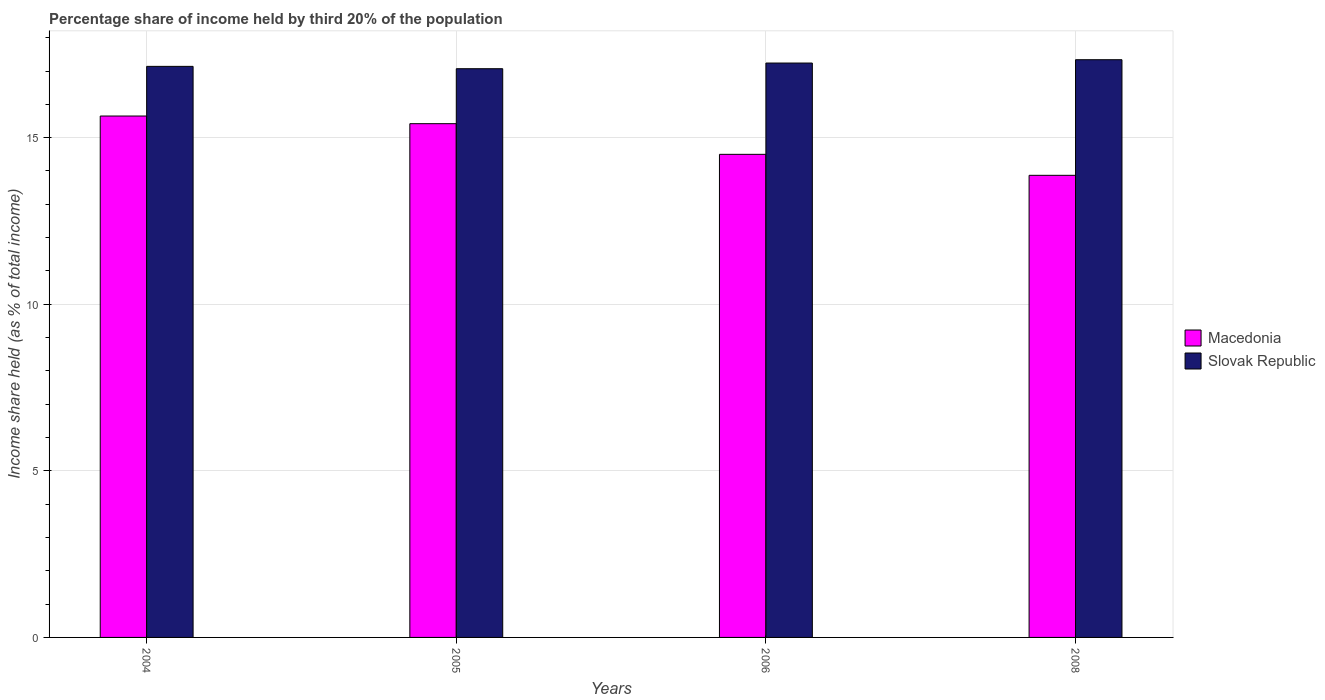How many groups of bars are there?
Offer a terse response. 4. Are the number of bars per tick equal to the number of legend labels?
Give a very brief answer. Yes. How many bars are there on the 1st tick from the right?
Provide a short and direct response. 2. In how many cases, is the number of bars for a given year not equal to the number of legend labels?
Your answer should be very brief. 0. What is the share of income held by third 20% of the population in Macedonia in 2008?
Ensure brevity in your answer.  13.87. Across all years, what is the maximum share of income held by third 20% of the population in Slovak Republic?
Keep it short and to the point. 17.34. Across all years, what is the minimum share of income held by third 20% of the population in Slovak Republic?
Keep it short and to the point. 17.07. What is the total share of income held by third 20% of the population in Slovak Republic in the graph?
Make the answer very short. 68.79. What is the difference between the share of income held by third 20% of the population in Slovak Republic in 2005 and that in 2008?
Keep it short and to the point. -0.27. What is the difference between the share of income held by third 20% of the population in Macedonia in 2006 and the share of income held by third 20% of the population in Slovak Republic in 2004?
Ensure brevity in your answer.  -2.64. What is the average share of income held by third 20% of the population in Macedonia per year?
Provide a succinct answer. 14.86. In the year 2008, what is the difference between the share of income held by third 20% of the population in Macedonia and share of income held by third 20% of the population in Slovak Republic?
Your answer should be very brief. -3.47. In how many years, is the share of income held by third 20% of the population in Macedonia greater than 6 %?
Your answer should be compact. 4. What is the ratio of the share of income held by third 20% of the population in Macedonia in 2004 to that in 2005?
Provide a succinct answer. 1.01. Is the difference between the share of income held by third 20% of the population in Macedonia in 2006 and 2008 greater than the difference between the share of income held by third 20% of the population in Slovak Republic in 2006 and 2008?
Offer a terse response. Yes. What is the difference between the highest and the second highest share of income held by third 20% of the population in Macedonia?
Give a very brief answer. 0.23. What is the difference between the highest and the lowest share of income held by third 20% of the population in Macedonia?
Your answer should be very brief. 1.78. In how many years, is the share of income held by third 20% of the population in Slovak Republic greater than the average share of income held by third 20% of the population in Slovak Republic taken over all years?
Offer a very short reply. 2. Is the sum of the share of income held by third 20% of the population in Macedonia in 2004 and 2006 greater than the maximum share of income held by third 20% of the population in Slovak Republic across all years?
Provide a succinct answer. Yes. What does the 1st bar from the left in 2008 represents?
Provide a succinct answer. Macedonia. What does the 1st bar from the right in 2008 represents?
Give a very brief answer. Slovak Republic. How many bars are there?
Make the answer very short. 8. Are all the bars in the graph horizontal?
Keep it short and to the point. No. How many years are there in the graph?
Ensure brevity in your answer.  4. Are the values on the major ticks of Y-axis written in scientific E-notation?
Provide a succinct answer. No. Does the graph contain any zero values?
Keep it short and to the point. No. Where does the legend appear in the graph?
Your response must be concise. Center right. How many legend labels are there?
Offer a terse response. 2. What is the title of the graph?
Provide a succinct answer. Percentage share of income held by third 20% of the population. What is the label or title of the X-axis?
Keep it short and to the point. Years. What is the label or title of the Y-axis?
Your answer should be compact. Income share held (as % of total income). What is the Income share held (as % of total income) of Macedonia in 2004?
Give a very brief answer. 15.65. What is the Income share held (as % of total income) of Slovak Republic in 2004?
Your answer should be very brief. 17.14. What is the Income share held (as % of total income) in Macedonia in 2005?
Ensure brevity in your answer.  15.42. What is the Income share held (as % of total income) of Slovak Republic in 2005?
Keep it short and to the point. 17.07. What is the Income share held (as % of total income) of Slovak Republic in 2006?
Provide a short and direct response. 17.24. What is the Income share held (as % of total income) in Macedonia in 2008?
Ensure brevity in your answer.  13.87. What is the Income share held (as % of total income) of Slovak Republic in 2008?
Ensure brevity in your answer.  17.34. Across all years, what is the maximum Income share held (as % of total income) in Macedonia?
Offer a terse response. 15.65. Across all years, what is the maximum Income share held (as % of total income) of Slovak Republic?
Keep it short and to the point. 17.34. Across all years, what is the minimum Income share held (as % of total income) of Macedonia?
Offer a very short reply. 13.87. Across all years, what is the minimum Income share held (as % of total income) of Slovak Republic?
Keep it short and to the point. 17.07. What is the total Income share held (as % of total income) in Macedonia in the graph?
Provide a short and direct response. 59.44. What is the total Income share held (as % of total income) in Slovak Republic in the graph?
Keep it short and to the point. 68.79. What is the difference between the Income share held (as % of total income) of Macedonia in 2004 and that in 2005?
Provide a short and direct response. 0.23. What is the difference between the Income share held (as % of total income) in Slovak Republic in 2004 and that in 2005?
Keep it short and to the point. 0.07. What is the difference between the Income share held (as % of total income) of Macedonia in 2004 and that in 2006?
Give a very brief answer. 1.15. What is the difference between the Income share held (as % of total income) in Macedonia in 2004 and that in 2008?
Your answer should be very brief. 1.78. What is the difference between the Income share held (as % of total income) of Macedonia in 2005 and that in 2006?
Ensure brevity in your answer.  0.92. What is the difference between the Income share held (as % of total income) of Slovak Republic in 2005 and that in 2006?
Your answer should be compact. -0.17. What is the difference between the Income share held (as % of total income) of Macedonia in 2005 and that in 2008?
Provide a short and direct response. 1.55. What is the difference between the Income share held (as % of total income) of Slovak Republic in 2005 and that in 2008?
Offer a terse response. -0.27. What is the difference between the Income share held (as % of total income) in Macedonia in 2006 and that in 2008?
Your answer should be compact. 0.63. What is the difference between the Income share held (as % of total income) in Macedonia in 2004 and the Income share held (as % of total income) in Slovak Republic in 2005?
Make the answer very short. -1.42. What is the difference between the Income share held (as % of total income) of Macedonia in 2004 and the Income share held (as % of total income) of Slovak Republic in 2006?
Offer a terse response. -1.59. What is the difference between the Income share held (as % of total income) in Macedonia in 2004 and the Income share held (as % of total income) in Slovak Republic in 2008?
Offer a terse response. -1.69. What is the difference between the Income share held (as % of total income) of Macedonia in 2005 and the Income share held (as % of total income) of Slovak Republic in 2006?
Make the answer very short. -1.82. What is the difference between the Income share held (as % of total income) of Macedonia in 2005 and the Income share held (as % of total income) of Slovak Republic in 2008?
Ensure brevity in your answer.  -1.92. What is the difference between the Income share held (as % of total income) in Macedonia in 2006 and the Income share held (as % of total income) in Slovak Republic in 2008?
Give a very brief answer. -2.84. What is the average Income share held (as % of total income) of Macedonia per year?
Your answer should be very brief. 14.86. What is the average Income share held (as % of total income) in Slovak Republic per year?
Ensure brevity in your answer.  17.2. In the year 2004, what is the difference between the Income share held (as % of total income) in Macedonia and Income share held (as % of total income) in Slovak Republic?
Offer a very short reply. -1.49. In the year 2005, what is the difference between the Income share held (as % of total income) in Macedonia and Income share held (as % of total income) in Slovak Republic?
Keep it short and to the point. -1.65. In the year 2006, what is the difference between the Income share held (as % of total income) of Macedonia and Income share held (as % of total income) of Slovak Republic?
Keep it short and to the point. -2.74. In the year 2008, what is the difference between the Income share held (as % of total income) in Macedonia and Income share held (as % of total income) in Slovak Republic?
Offer a very short reply. -3.47. What is the ratio of the Income share held (as % of total income) of Macedonia in 2004 to that in 2005?
Make the answer very short. 1.01. What is the ratio of the Income share held (as % of total income) in Slovak Republic in 2004 to that in 2005?
Ensure brevity in your answer.  1. What is the ratio of the Income share held (as % of total income) in Macedonia in 2004 to that in 2006?
Provide a succinct answer. 1.08. What is the ratio of the Income share held (as % of total income) of Slovak Republic in 2004 to that in 2006?
Ensure brevity in your answer.  0.99. What is the ratio of the Income share held (as % of total income) of Macedonia in 2004 to that in 2008?
Give a very brief answer. 1.13. What is the ratio of the Income share held (as % of total income) in Slovak Republic in 2004 to that in 2008?
Your response must be concise. 0.99. What is the ratio of the Income share held (as % of total income) of Macedonia in 2005 to that in 2006?
Your answer should be compact. 1.06. What is the ratio of the Income share held (as % of total income) in Slovak Republic in 2005 to that in 2006?
Your answer should be compact. 0.99. What is the ratio of the Income share held (as % of total income) in Macedonia in 2005 to that in 2008?
Keep it short and to the point. 1.11. What is the ratio of the Income share held (as % of total income) in Slovak Republic in 2005 to that in 2008?
Your answer should be very brief. 0.98. What is the ratio of the Income share held (as % of total income) of Macedonia in 2006 to that in 2008?
Offer a terse response. 1.05. What is the ratio of the Income share held (as % of total income) of Slovak Republic in 2006 to that in 2008?
Your answer should be compact. 0.99. What is the difference between the highest and the second highest Income share held (as % of total income) in Macedonia?
Your response must be concise. 0.23. What is the difference between the highest and the lowest Income share held (as % of total income) of Macedonia?
Keep it short and to the point. 1.78. What is the difference between the highest and the lowest Income share held (as % of total income) of Slovak Republic?
Your response must be concise. 0.27. 